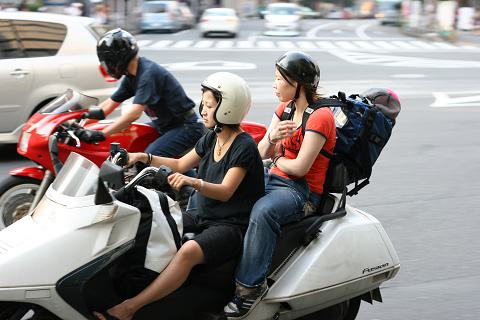How many cars would there be in the image if someone added two more cars in the picture? If two more cars were added to the scene captured in the image, there would be a total of 5 cars. The scene currently shows a busy street, adding more vehicles would make it even more bustling, possibly reflecting a typical busy day in an urban setting. 